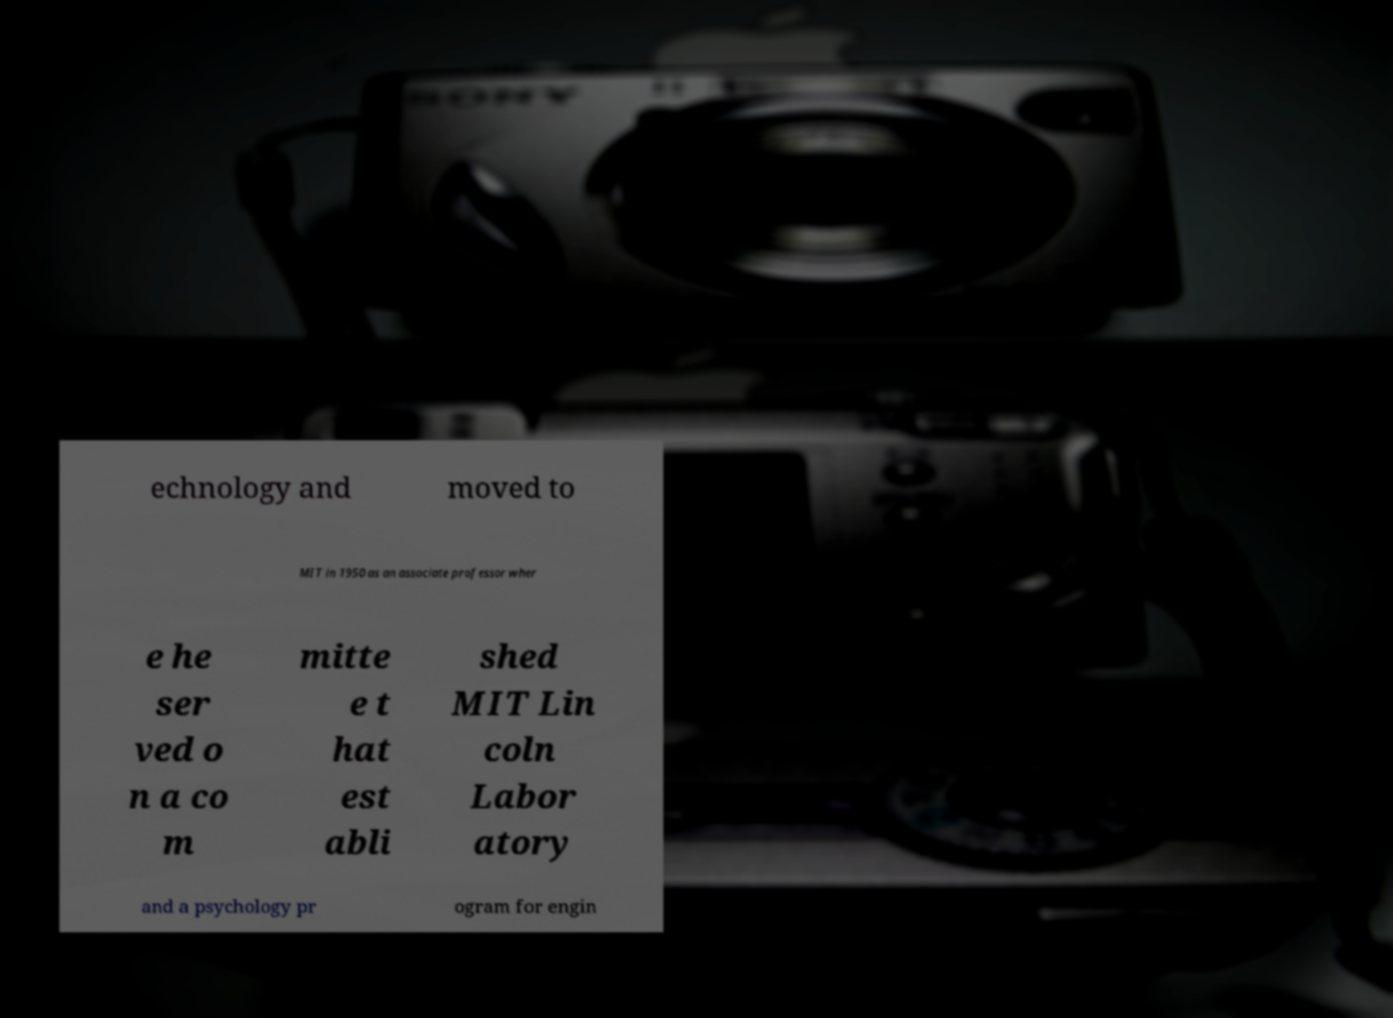Please identify and transcribe the text found in this image. echnology and moved to MIT in 1950 as an associate professor wher e he ser ved o n a co m mitte e t hat est abli shed MIT Lin coln Labor atory and a psychology pr ogram for engin 